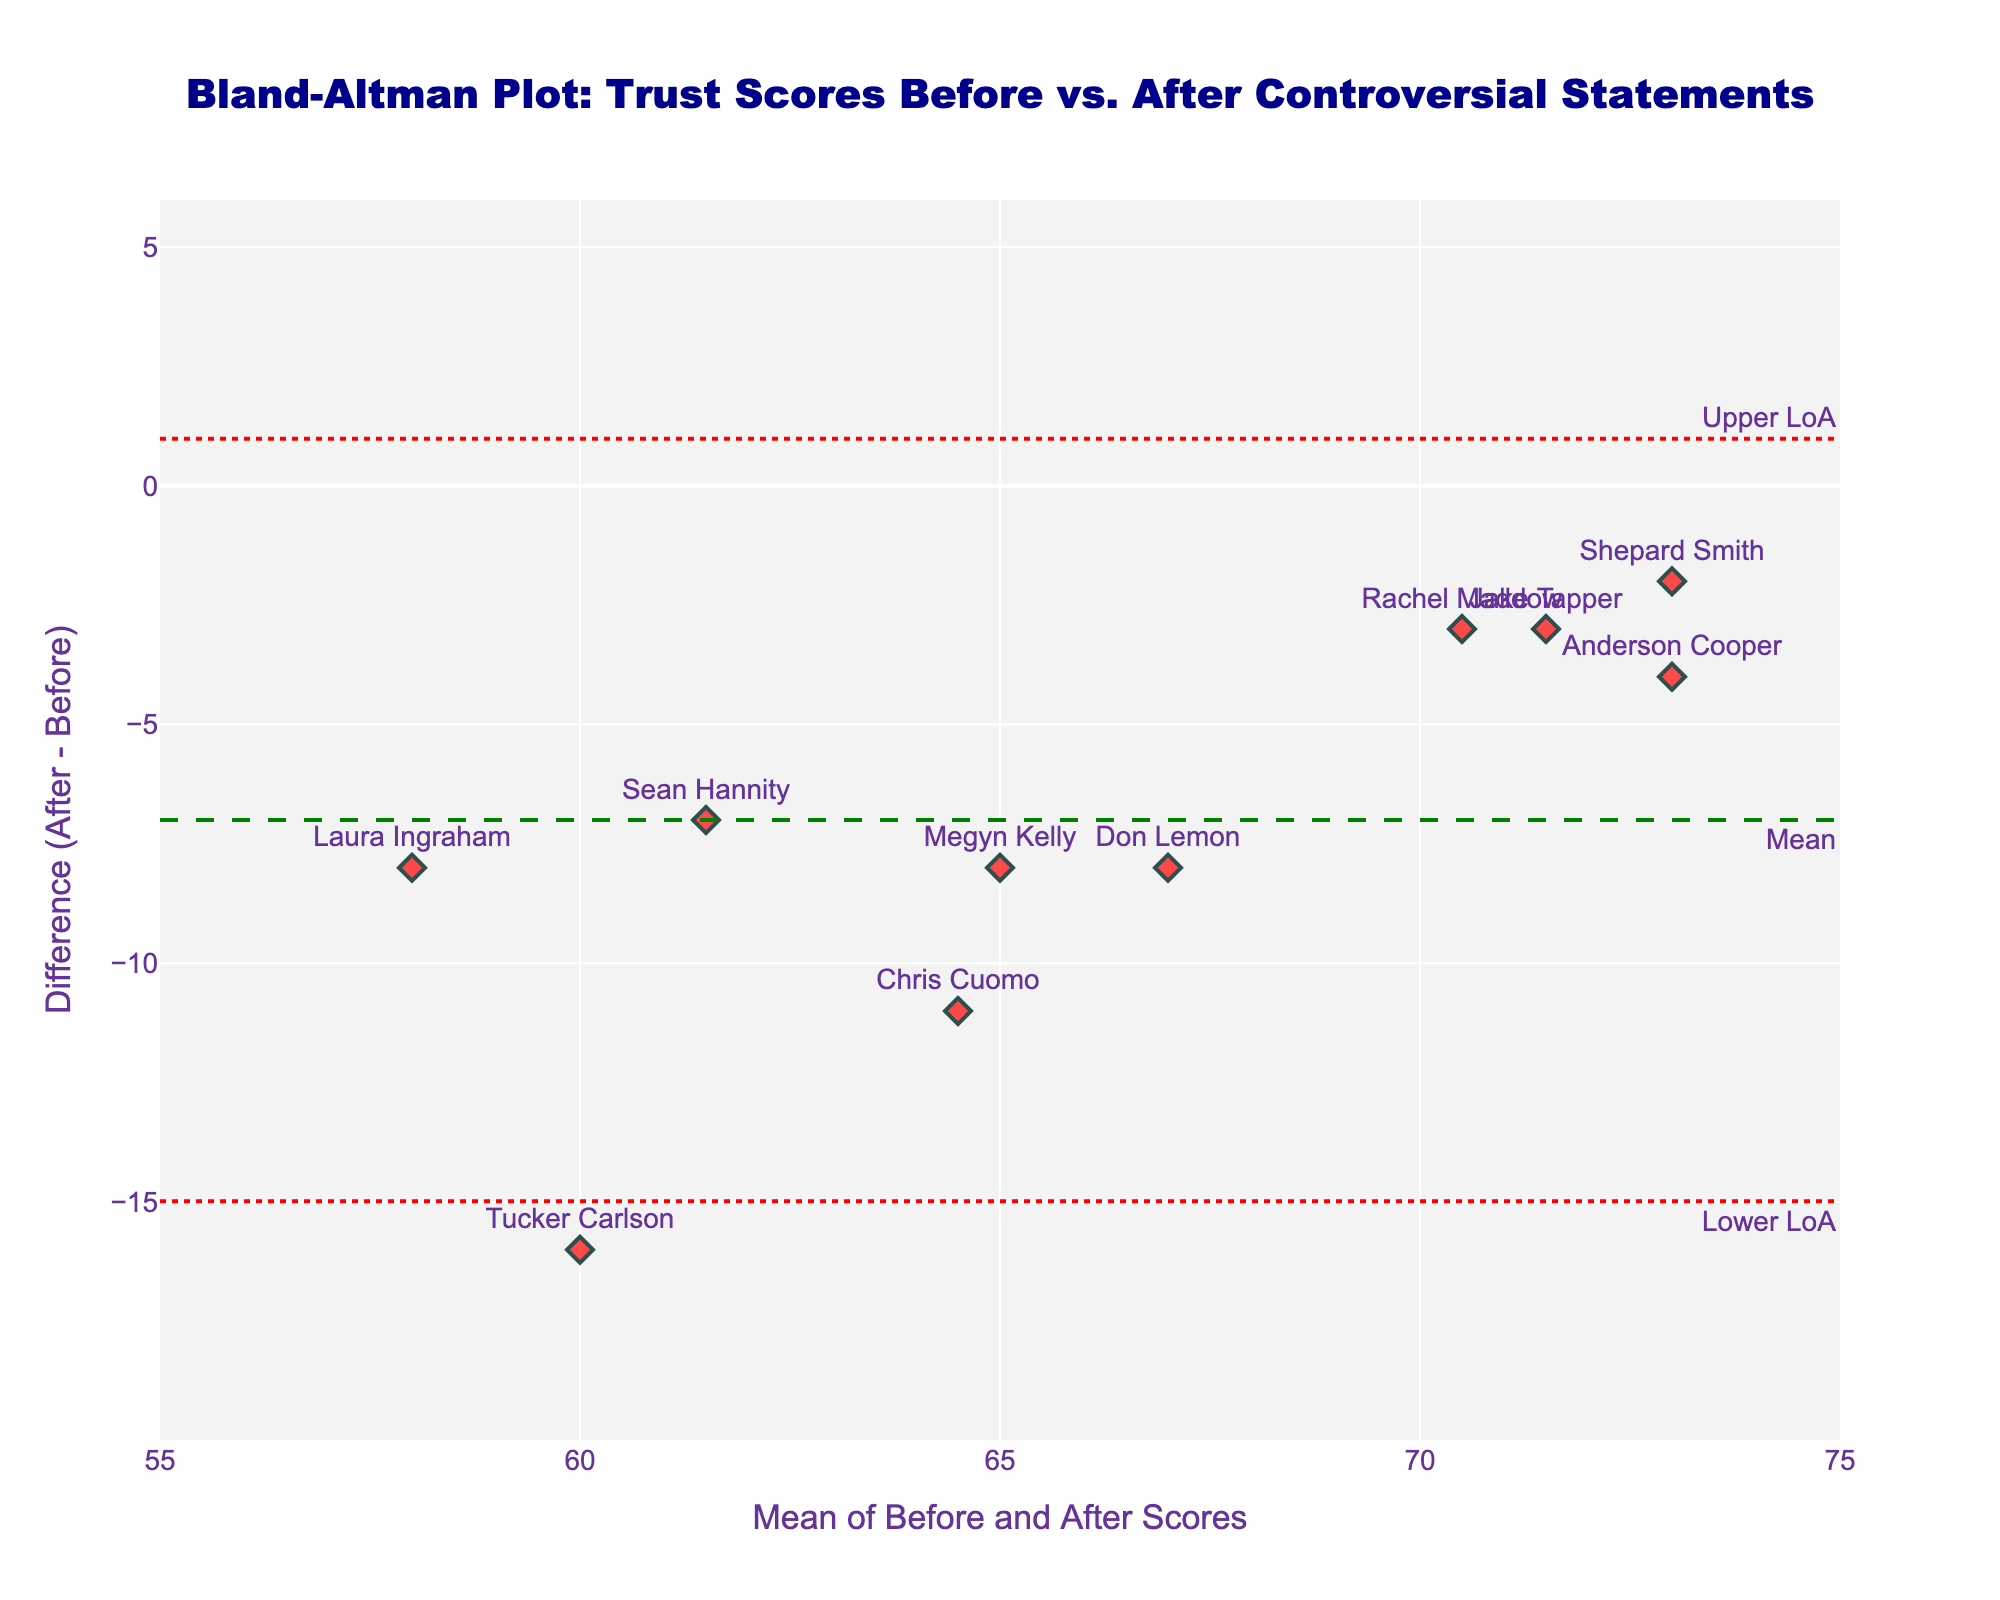How many anchors have a negative difference in trust scores after the controversial statements? To determine this, count the data points below the zero line on the y-axis, representing a negative difference in trust scores. There are 10 data points all below 0.
Answer: 10 What does the green dashed line represent in the plot? The green dashed line represents the mean difference between the "before" and "after" trust scores, serving as an indicator of the average change in public trust.
Answer: Mean difference What is the range of differences (After - Before) observed in the data? The range can be determined by subtracting the smallest y-value (difference) from the largest y-value. The smallest difference is -16, and the largest is -2. The range is -2 - (-16) = 14.
Answer: 14 Which anchor has the smallest change in trust scores between "before" and "after" statements? Identify the anchor with the smallest difference value on the plot. The smallest difference is -2, which belongs to Shepard Smith.
Answer: Shepard Smith What are the upper and lower limits of agreement? The limits of agreement (LoA) are the red dotted lines. The upper and lower LoA values are calculated based on mean difference and standard deviation. By observing the plot, we can see the upper LoA is approximately 3, and the lower LoA is approximately -19.
Answer: 3 and -19 Is there any anchor that has an "after" score higher than the "before" score? Check if any data points are above the 0 line (y-axis) on the plot. There are none displayed above this line, indicating all anchors experienced a decrease in trust scores.
Answer: No Which anchor had the most significant drop in trust scores? Identify the anchor closest to the most negative y-value on the plot. The most significant drop is observed at y = -16, which corresponds to Tucker Carlson.
Answer: Tucker Carlson How many anchors have a mean trust score between 60 and 70? Count the data points along the x-axis that fall between 60 and 70. There are six such anchors, indicated by the locations of the data points within the specified range.
Answer: 6 Which side of the mean difference line do most of the anchors fall on? Observing the plot, most data points are below the green dashed mean line.
Answer: Below What does it mean if a data point falls above the upper limit of agreement? If a data point falls above the upper limit of agreement (red dotted line), it indicates that the change in trust for that anchor is significantly higher than what is expected based on the mean difference and standard deviation.
Answer: Significant increase 